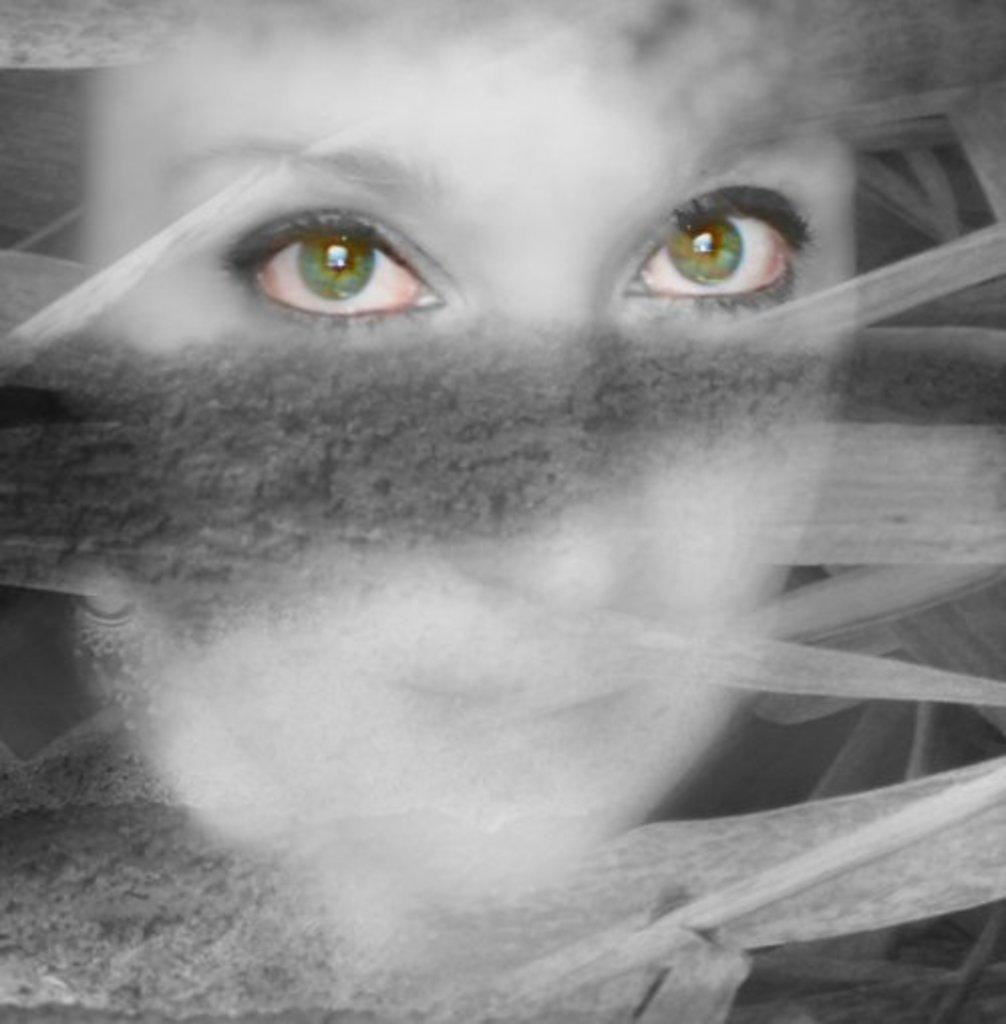What is the main subject of the image? The main subject of the image is human eyes. Can you describe the eyes in the image? The image contains human eyes, but no further details are provided. What type of nail is being hammered during the meeting in the image? There is no nail or meeting present in the image; it only contains human eyes. 